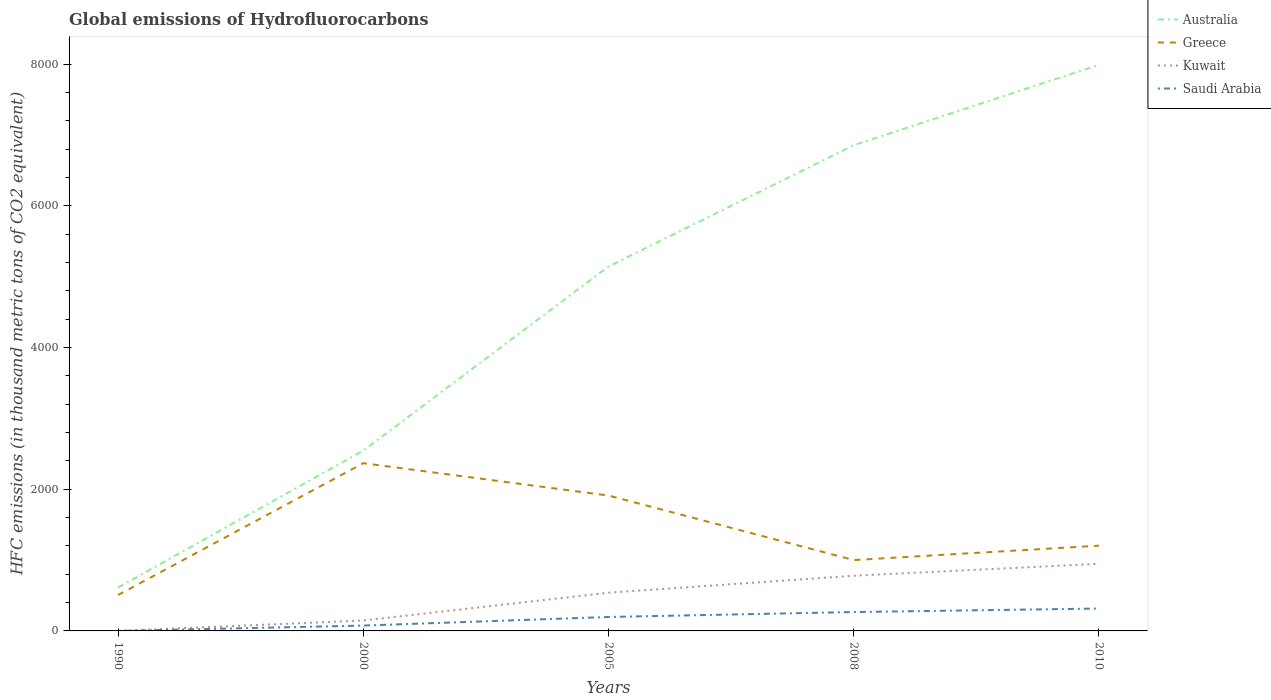Is the number of lines equal to the number of legend labels?
Provide a succinct answer. Yes. Across all years, what is the maximum global emissions of Hydrofluorocarbons in Australia?
Provide a short and direct response. 612.5. In which year was the global emissions of Hydrofluorocarbons in Australia maximum?
Your answer should be very brief. 1990. What is the total global emissions of Hydrofluorocarbons in Saudi Arabia in the graph?
Provide a succinct answer. -196.8. What is the difference between the highest and the second highest global emissions of Hydrofluorocarbons in Kuwait?
Ensure brevity in your answer.  947.9. How many years are there in the graph?
Make the answer very short. 5. What is the difference between two consecutive major ticks on the Y-axis?
Provide a short and direct response. 2000. Does the graph contain any zero values?
Provide a short and direct response. No. Does the graph contain grids?
Provide a succinct answer. No. Where does the legend appear in the graph?
Your response must be concise. Top right. How are the legend labels stacked?
Give a very brief answer. Vertical. What is the title of the graph?
Give a very brief answer. Global emissions of Hydrofluorocarbons. Does "Haiti" appear as one of the legend labels in the graph?
Give a very brief answer. No. What is the label or title of the Y-axis?
Ensure brevity in your answer.  HFC emissions (in thousand metric tons of CO2 equivalent). What is the HFC emissions (in thousand metric tons of CO2 equivalent) in Australia in 1990?
Make the answer very short. 612.5. What is the HFC emissions (in thousand metric tons of CO2 equivalent) in Greece in 1990?
Offer a very short reply. 507.2. What is the HFC emissions (in thousand metric tons of CO2 equivalent) of Australia in 2000?
Offer a very short reply. 2545.7. What is the HFC emissions (in thousand metric tons of CO2 equivalent) in Greece in 2000?
Give a very brief answer. 2368.4. What is the HFC emissions (in thousand metric tons of CO2 equivalent) of Kuwait in 2000?
Ensure brevity in your answer.  147.3. What is the HFC emissions (in thousand metric tons of CO2 equivalent) of Saudi Arabia in 2000?
Your response must be concise. 75.5. What is the HFC emissions (in thousand metric tons of CO2 equivalent) of Australia in 2005?
Keep it short and to the point. 5145.6. What is the HFC emissions (in thousand metric tons of CO2 equivalent) of Greece in 2005?
Your response must be concise. 1911.4. What is the HFC emissions (in thousand metric tons of CO2 equivalent) of Kuwait in 2005?
Make the answer very short. 539.6. What is the HFC emissions (in thousand metric tons of CO2 equivalent) of Saudi Arabia in 2005?
Your answer should be compact. 196.9. What is the HFC emissions (in thousand metric tons of CO2 equivalent) in Australia in 2008?
Offer a very short reply. 6857.4. What is the HFC emissions (in thousand metric tons of CO2 equivalent) in Greece in 2008?
Ensure brevity in your answer.  1000.3. What is the HFC emissions (in thousand metric tons of CO2 equivalent) of Kuwait in 2008?
Offer a terse response. 779. What is the HFC emissions (in thousand metric tons of CO2 equivalent) of Saudi Arabia in 2008?
Your answer should be compact. 266.5. What is the HFC emissions (in thousand metric tons of CO2 equivalent) of Australia in 2010?
Your answer should be very brief. 7992. What is the HFC emissions (in thousand metric tons of CO2 equivalent) in Greece in 2010?
Make the answer very short. 1204. What is the HFC emissions (in thousand metric tons of CO2 equivalent) in Kuwait in 2010?
Your answer should be compact. 948. What is the HFC emissions (in thousand metric tons of CO2 equivalent) in Saudi Arabia in 2010?
Ensure brevity in your answer.  316. Across all years, what is the maximum HFC emissions (in thousand metric tons of CO2 equivalent) of Australia?
Your answer should be compact. 7992. Across all years, what is the maximum HFC emissions (in thousand metric tons of CO2 equivalent) in Greece?
Your answer should be compact. 2368.4. Across all years, what is the maximum HFC emissions (in thousand metric tons of CO2 equivalent) in Kuwait?
Make the answer very short. 948. Across all years, what is the maximum HFC emissions (in thousand metric tons of CO2 equivalent) in Saudi Arabia?
Your answer should be compact. 316. Across all years, what is the minimum HFC emissions (in thousand metric tons of CO2 equivalent) of Australia?
Keep it short and to the point. 612.5. Across all years, what is the minimum HFC emissions (in thousand metric tons of CO2 equivalent) in Greece?
Your answer should be compact. 507.2. What is the total HFC emissions (in thousand metric tons of CO2 equivalent) in Australia in the graph?
Provide a succinct answer. 2.32e+04. What is the total HFC emissions (in thousand metric tons of CO2 equivalent) of Greece in the graph?
Your answer should be very brief. 6991.3. What is the total HFC emissions (in thousand metric tons of CO2 equivalent) of Kuwait in the graph?
Make the answer very short. 2414. What is the total HFC emissions (in thousand metric tons of CO2 equivalent) of Saudi Arabia in the graph?
Your answer should be very brief. 855. What is the difference between the HFC emissions (in thousand metric tons of CO2 equivalent) in Australia in 1990 and that in 2000?
Your response must be concise. -1933.2. What is the difference between the HFC emissions (in thousand metric tons of CO2 equivalent) in Greece in 1990 and that in 2000?
Offer a very short reply. -1861.2. What is the difference between the HFC emissions (in thousand metric tons of CO2 equivalent) of Kuwait in 1990 and that in 2000?
Keep it short and to the point. -147.2. What is the difference between the HFC emissions (in thousand metric tons of CO2 equivalent) of Saudi Arabia in 1990 and that in 2000?
Make the answer very short. -75.4. What is the difference between the HFC emissions (in thousand metric tons of CO2 equivalent) in Australia in 1990 and that in 2005?
Ensure brevity in your answer.  -4533.1. What is the difference between the HFC emissions (in thousand metric tons of CO2 equivalent) in Greece in 1990 and that in 2005?
Give a very brief answer. -1404.2. What is the difference between the HFC emissions (in thousand metric tons of CO2 equivalent) in Kuwait in 1990 and that in 2005?
Make the answer very short. -539.5. What is the difference between the HFC emissions (in thousand metric tons of CO2 equivalent) of Saudi Arabia in 1990 and that in 2005?
Keep it short and to the point. -196.8. What is the difference between the HFC emissions (in thousand metric tons of CO2 equivalent) of Australia in 1990 and that in 2008?
Your answer should be compact. -6244.9. What is the difference between the HFC emissions (in thousand metric tons of CO2 equivalent) in Greece in 1990 and that in 2008?
Give a very brief answer. -493.1. What is the difference between the HFC emissions (in thousand metric tons of CO2 equivalent) of Kuwait in 1990 and that in 2008?
Your answer should be compact. -778.9. What is the difference between the HFC emissions (in thousand metric tons of CO2 equivalent) of Saudi Arabia in 1990 and that in 2008?
Your response must be concise. -266.4. What is the difference between the HFC emissions (in thousand metric tons of CO2 equivalent) of Australia in 1990 and that in 2010?
Keep it short and to the point. -7379.5. What is the difference between the HFC emissions (in thousand metric tons of CO2 equivalent) in Greece in 1990 and that in 2010?
Ensure brevity in your answer.  -696.8. What is the difference between the HFC emissions (in thousand metric tons of CO2 equivalent) in Kuwait in 1990 and that in 2010?
Give a very brief answer. -947.9. What is the difference between the HFC emissions (in thousand metric tons of CO2 equivalent) of Saudi Arabia in 1990 and that in 2010?
Your response must be concise. -315.9. What is the difference between the HFC emissions (in thousand metric tons of CO2 equivalent) in Australia in 2000 and that in 2005?
Provide a short and direct response. -2599.9. What is the difference between the HFC emissions (in thousand metric tons of CO2 equivalent) in Greece in 2000 and that in 2005?
Your answer should be compact. 457. What is the difference between the HFC emissions (in thousand metric tons of CO2 equivalent) in Kuwait in 2000 and that in 2005?
Provide a short and direct response. -392.3. What is the difference between the HFC emissions (in thousand metric tons of CO2 equivalent) of Saudi Arabia in 2000 and that in 2005?
Offer a very short reply. -121.4. What is the difference between the HFC emissions (in thousand metric tons of CO2 equivalent) of Australia in 2000 and that in 2008?
Ensure brevity in your answer.  -4311.7. What is the difference between the HFC emissions (in thousand metric tons of CO2 equivalent) of Greece in 2000 and that in 2008?
Ensure brevity in your answer.  1368.1. What is the difference between the HFC emissions (in thousand metric tons of CO2 equivalent) in Kuwait in 2000 and that in 2008?
Your answer should be very brief. -631.7. What is the difference between the HFC emissions (in thousand metric tons of CO2 equivalent) in Saudi Arabia in 2000 and that in 2008?
Provide a succinct answer. -191. What is the difference between the HFC emissions (in thousand metric tons of CO2 equivalent) of Australia in 2000 and that in 2010?
Your answer should be very brief. -5446.3. What is the difference between the HFC emissions (in thousand metric tons of CO2 equivalent) in Greece in 2000 and that in 2010?
Offer a very short reply. 1164.4. What is the difference between the HFC emissions (in thousand metric tons of CO2 equivalent) in Kuwait in 2000 and that in 2010?
Provide a short and direct response. -800.7. What is the difference between the HFC emissions (in thousand metric tons of CO2 equivalent) in Saudi Arabia in 2000 and that in 2010?
Ensure brevity in your answer.  -240.5. What is the difference between the HFC emissions (in thousand metric tons of CO2 equivalent) in Australia in 2005 and that in 2008?
Provide a succinct answer. -1711.8. What is the difference between the HFC emissions (in thousand metric tons of CO2 equivalent) in Greece in 2005 and that in 2008?
Keep it short and to the point. 911.1. What is the difference between the HFC emissions (in thousand metric tons of CO2 equivalent) in Kuwait in 2005 and that in 2008?
Keep it short and to the point. -239.4. What is the difference between the HFC emissions (in thousand metric tons of CO2 equivalent) in Saudi Arabia in 2005 and that in 2008?
Offer a very short reply. -69.6. What is the difference between the HFC emissions (in thousand metric tons of CO2 equivalent) of Australia in 2005 and that in 2010?
Provide a succinct answer. -2846.4. What is the difference between the HFC emissions (in thousand metric tons of CO2 equivalent) of Greece in 2005 and that in 2010?
Keep it short and to the point. 707.4. What is the difference between the HFC emissions (in thousand metric tons of CO2 equivalent) of Kuwait in 2005 and that in 2010?
Offer a terse response. -408.4. What is the difference between the HFC emissions (in thousand metric tons of CO2 equivalent) of Saudi Arabia in 2005 and that in 2010?
Your answer should be compact. -119.1. What is the difference between the HFC emissions (in thousand metric tons of CO2 equivalent) in Australia in 2008 and that in 2010?
Keep it short and to the point. -1134.6. What is the difference between the HFC emissions (in thousand metric tons of CO2 equivalent) of Greece in 2008 and that in 2010?
Provide a short and direct response. -203.7. What is the difference between the HFC emissions (in thousand metric tons of CO2 equivalent) in Kuwait in 2008 and that in 2010?
Offer a very short reply. -169. What is the difference between the HFC emissions (in thousand metric tons of CO2 equivalent) of Saudi Arabia in 2008 and that in 2010?
Give a very brief answer. -49.5. What is the difference between the HFC emissions (in thousand metric tons of CO2 equivalent) in Australia in 1990 and the HFC emissions (in thousand metric tons of CO2 equivalent) in Greece in 2000?
Provide a succinct answer. -1755.9. What is the difference between the HFC emissions (in thousand metric tons of CO2 equivalent) in Australia in 1990 and the HFC emissions (in thousand metric tons of CO2 equivalent) in Kuwait in 2000?
Offer a terse response. 465.2. What is the difference between the HFC emissions (in thousand metric tons of CO2 equivalent) of Australia in 1990 and the HFC emissions (in thousand metric tons of CO2 equivalent) of Saudi Arabia in 2000?
Give a very brief answer. 537. What is the difference between the HFC emissions (in thousand metric tons of CO2 equivalent) in Greece in 1990 and the HFC emissions (in thousand metric tons of CO2 equivalent) in Kuwait in 2000?
Offer a terse response. 359.9. What is the difference between the HFC emissions (in thousand metric tons of CO2 equivalent) in Greece in 1990 and the HFC emissions (in thousand metric tons of CO2 equivalent) in Saudi Arabia in 2000?
Keep it short and to the point. 431.7. What is the difference between the HFC emissions (in thousand metric tons of CO2 equivalent) in Kuwait in 1990 and the HFC emissions (in thousand metric tons of CO2 equivalent) in Saudi Arabia in 2000?
Make the answer very short. -75.4. What is the difference between the HFC emissions (in thousand metric tons of CO2 equivalent) in Australia in 1990 and the HFC emissions (in thousand metric tons of CO2 equivalent) in Greece in 2005?
Give a very brief answer. -1298.9. What is the difference between the HFC emissions (in thousand metric tons of CO2 equivalent) in Australia in 1990 and the HFC emissions (in thousand metric tons of CO2 equivalent) in Kuwait in 2005?
Keep it short and to the point. 72.9. What is the difference between the HFC emissions (in thousand metric tons of CO2 equivalent) in Australia in 1990 and the HFC emissions (in thousand metric tons of CO2 equivalent) in Saudi Arabia in 2005?
Offer a terse response. 415.6. What is the difference between the HFC emissions (in thousand metric tons of CO2 equivalent) in Greece in 1990 and the HFC emissions (in thousand metric tons of CO2 equivalent) in Kuwait in 2005?
Your response must be concise. -32.4. What is the difference between the HFC emissions (in thousand metric tons of CO2 equivalent) in Greece in 1990 and the HFC emissions (in thousand metric tons of CO2 equivalent) in Saudi Arabia in 2005?
Your answer should be very brief. 310.3. What is the difference between the HFC emissions (in thousand metric tons of CO2 equivalent) in Kuwait in 1990 and the HFC emissions (in thousand metric tons of CO2 equivalent) in Saudi Arabia in 2005?
Offer a very short reply. -196.8. What is the difference between the HFC emissions (in thousand metric tons of CO2 equivalent) of Australia in 1990 and the HFC emissions (in thousand metric tons of CO2 equivalent) of Greece in 2008?
Your answer should be very brief. -387.8. What is the difference between the HFC emissions (in thousand metric tons of CO2 equivalent) of Australia in 1990 and the HFC emissions (in thousand metric tons of CO2 equivalent) of Kuwait in 2008?
Provide a succinct answer. -166.5. What is the difference between the HFC emissions (in thousand metric tons of CO2 equivalent) of Australia in 1990 and the HFC emissions (in thousand metric tons of CO2 equivalent) of Saudi Arabia in 2008?
Your response must be concise. 346. What is the difference between the HFC emissions (in thousand metric tons of CO2 equivalent) of Greece in 1990 and the HFC emissions (in thousand metric tons of CO2 equivalent) of Kuwait in 2008?
Give a very brief answer. -271.8. What is the difference between the HFC emissions (in thousand metric tons of CO2 equivalent) of Greece in 1990 and the HFC emissions (in thousand metric tons of CO2 equivalent) of Saudi Arabia in 2008?
Your answer should be compact. 240.7. What is the difference between the HFC emissions (in thousand metric tons of CO2 equivalent) in Kuwait in 1990 and the HFC emissions (in thousand metric tons of CO2 equivalent) in Saudi Arabia in 2008?
Keep it short and to the point. -266.4. What is the difference between the HFC emissions (in thousand metric tons of CO2 equivalent) of Australia in 1990 and the HFC emissions (in thousand metric tons of CO2 equivalent) of Greece in 2010?
Offer a terse response. -591.5. What is the difference between the HFC emissions (in thousand metric tons of CO2 equivalent) in Australia in 1990 and the HFC emissions (in thousand metric tons of CO2 equivalent) in Kuwait in 2010?
Provide a succinct answer. -335.5. What is the difference between the HFC emissions (in thousand metric tons of CO2 equivalent) of Australia in 1990 and the HFC emissions (in thousand metric tons of CO2 equivalent) of Saudi Arabia in 2010?
Your answer should be very brief. 296.5. What is the difference between the HFC emissions (in thousand metric tons of CO2 equivalent) of Greece in 1990 and the HFC emissions (in thousand metric tons of CO2 equivalent) of Kuwait in 2010?
Give a very brief answer. -440.8. What is the difference between the HFC emissions (in thousand metric tons of CO2 equivalent) in Greece in 1990 and the HFC emissions (in thousand metric tons of CO2 equivalent) in Saudi Arabia in 2010?
Your response must be concise. 191.2. What is the difference between the HFC emissions (in thousand metric tons of CO2 equivalent) in Kuwait in 1990 and the HFC emissions (in thousand metric tons of CO2 equivalent) in Saudi Arabia in 2010?
Provide a succinct answer. -315.9. What is the difference between the HFC emissions (in thousand metric tons of CO2 equivalent) of Australia in 2000 and the HFC emissions (in thousand metric tons of CO2 equivalent) of Greece in 2005?
Make the answer very short. 634.3. What is the difference between the HFC emissions (in thousand metric tons of CO2 equivalent) of Australia in 2000 and the HFC emissions (in thousand metric tons of CO2 equivalent) of Kuwait in 2005?
Your response must be concise. 2006.1. What is the difference between the HFC emissions (in thousand metric tons of CO2 equivalent) of Australia in 2000 and the HFC emissions (in thousand metric tons of CO2 equivalent) of Saudi Arabia in 2005?
Offer a terse response. 2348.8. What is the difference between the HFC emissions (in thousand metric tons of CO2 equivalent) in Greece in 2000 and the HFC emissions (in thousand metric tons of CO2 equivalent) in Kuwait in 2005?
Your answer should be compact. 1828.8. What is the difference between the HFC emissions (in thousand metric tons of CO2 equivalent) in Greece in 2000 and the HFC emissions (in thousand metric tons of CO2 equivalent) in Saudi Arabia in 2005?
Keep it short and to the point. 2171.5. What is the difference between the HFC emissions (in thousand metric tons of CO2 equivalent) of Kuwait in 2000 and the HFC emissions (in thousand metric tons of CO2 equivalent) of Saudi Arabia in 2005?
Your response must be concise. -49.6. What is the difference between the HFC emissions (in thousand metric tons of CO2 equivalent) in Australia in 2000 and the HFC emissions (in thousand metric tons of CO2 equivalent) in Greece in 2008?
Offer a very short reply. 1545.4. What is the difference between the HFC emissions (in thousand metric tons of CO2 equivalent) in Australia in 2000 and the HFC emissions (in thousand metric tons of CO2 equivalent) in Kuwait in 2008?
Your answer should be compact. 1766.7. What is the difference between the HFC emissions (in thousand metric tons of CO2 equivalent) in Australia in 2000 and the HFC emissions (in thousand metric tons of CO2 equivalent) in Saudi Arabia in 2008?
Your answer should be compact. 2279.2. What is the difference between the HFC emissions (in thousand metric tons of CO2 equivalent) in Greece in 2000 and the HFC emissions (in thousand metric tons of CO2 equivalent) in Kuwait in 2008?
Your answer should be compact. 1589.4. What is the difference between the HFC emissions (in thousand metric tons of CO2 equivalent) in Greece in 2000 and the HFC emissions (in thousand metric tons of CO2 equivalent) in Saudi Arabia in 2008?
Keep it short and to the point. 2101.9. What is the difference between the HFC emissions (in thousand metric tons of CO2 equivalent) in Kuwait in 2000 and the HFC emissions (in thousand metric tons of CO2 equivalent) in Saudi Arabia in 2008?
Your answer should be very brief. -119.2. What is the difference between the HFC emissions (in thousand metric tons of CO2 equivalent) of Australia in 2000 and the HFC emissions (in thousand metric tons of CO2 equivalent) of Greece in 2010?
Make the answer very short. 1341.7. What is the difference between the HFC emissions (in thousand metric tons of CO2 equivalent) in Australia in 2000 and the HFC emissions (in thousand metric tons of CO2 equivalent) in Kuwait in 2010?
Offer a very short reply. 1597.7. What is the difference between the HFC emissions (in thousand metric tons of CO2 equivalent) in Australia in 2000 and the HFC emissions (in thousand metric tons of CO2 equivalent) in Saudi Arabia in 2010?
Give a very brief answer. 2229.7. What is the difference between the HFC emissions (in thousand metric tons of CO2 equivalent) of Greece in 2000 and the HFC emissions (in thousand metric tons of CO2 equivalent) of Kuwait in 2010?
Offer a terse response. 1420.4. What is the difference between the HFC emissions (in thousand metric tons of CO2 equivalent) of Greece in 2000 and the HFC emissions (in thousand metric tons of CO2 equivalent) of Saudi Arabia in 2010?
Your response must be concise. 2052.4. What is the difference between the HFC emissions (in thousand metric tons of CO2 equivalent) of Kuwait in 2000 and the HFC emissions (in thousand metric tons of CO2 equivalent) of Saudi Arabia in 2010?
Give a very brief answer. -168.7. What is the difference between the HFC emissions (in thousand metric tons of CO2 equivalent) of Australia in 2005 and the HFC emissions (in thousand metric tons of CO2 equivalent) of Greece in 2008?
Ensure brevity in your answer.  4145.3. What is the difference between the HFC emissions (in thousand metric tons of CO2 equivalent) in Australia in 2005 and the HFC emissions (in thousand metric tons of CO2 equivalent) in Kuwait in 2008?
Your answer should be compact. 4366.6. What is the difference between the HFC emissions (in thousand metric tons of CO2 equivalent) in Australia in 2005 and the HFC emissions (in thousand metric tons of CO2 equivalent) in Saudi Arabia in 2008?
Offer a very short reply. 4879.1. What is the difference between the HFC emissions (in thousand metric tons of CO2 equivalent) in Greece in 2005 and the HFC emissions (in thousand metric tons of CO2 equivalent) in Kuwait in 2008?
Ensure brevity in your answer.  1132.4. What is the difference between the HFC emissions (in thousand metric tons of CO2 equivalent) in Greece in 2005 and the HFC emissions (in thousand metric tons of CO2 equivalent) in Saudi Arabia in 2008?
Give a very brief answer. 1644.9. What is the difference between the HFC emissions (in thousand metric tons of CO2 equivalent) in Kuwait in 2005 and the HFC emissions (in thousand metric tons of CO2 equivalent) in Saudi Arabia in 2008?
Keep it short and to the point. 273.1. What is the difference between the HFC emissions (in thousand metric tons of CO2 equivalent) of Australia in 2005 and the HFC emissions (in thousand metric tons of CO2 equivalent) of Greece in 2010?
Provide a short and direct response. 3941.6. What is the difference between the HFC emissions (in thousand metric tons of CO2 equivalent) of Australia in 2005 and the HFC emissions (in thousand metric tons of CO2 equivalent) of Kuwait in 2010?
Your answer should be compact. 4197.6. What is the difference between the HFC emissions (in thousand metric tons of CO2 equivalent) of Australia in 2005 and the HFC emissions (in thousand metric tons of CO2 equivalent) of Saudi Arabia in 2010?
Make the answer very short. 4829.6. What is the difference between the HFC emissions (in thousand metric tons of CO2 equivalent) of Greece in 2005 and the HFC emissions (in thousand metric tons of CO2 equivalent) of Kuwait in 2010?
Your answer should be compact. 963.4. What is the difference between the HFC emissions (in thousand metric tons of CO2 equivalent) in Greece in 2005 and the HFC emissions (in thousand metric tons of CO2 equivalent) in Saudi Arabia in 2010?
Your response must be concise. 1595.4. What is the difference between the HFC emissions (in thousand metric tons of CO2 equivalent) of Kuwait in 2005 and the HFC emissions (in thousand metric tons of CO2 equivalent) of Saudi Arabia in 2010?
Your answer should be very brief. 223.6. What is the difference between the HFC emissions (in thousand metric tons of CO2 equivalent) in Australia in 2008 and the HFC emissions (in thousand metric tons of CO2 equivalent) in Greece in 2010?
Your answer should be compact. 5653.4. What is the difference between the HFC emissions (in thousand metric tons of CO2 equivalent) in Australia in 2008 and the HFC emissions (in thousand metric tons of CO2 equivalent) in Kuwait in 2010?
Give a very brief answer. 5909.4. What is the difference between the HFC emissions (in thousand metric tons of CO2 equivalent) in Australia in 2008 and the HFC emissions (in thousand metric tons of CO2 equivalent) in Saudi Arabia in 2010?
Offer a terse response. 6541.4. What is the difference between the HFC emissions (in thousand metric tons of CO2 equivalent) in Greece in 2008 and the HFC emissions (in thousand metric tons of CO2 equivalent) in Kuwait in 2010?
Make the answer very short. 52.3. What is the difference between the HFC emissions (in thousand metric tons of CO2 equivalent) in Greece in 2008 and the HFC emissions (in thousand metric tons of CO2 equivalent) in Saudi Arabia in 2010?
Provide a short and direct response. 684.3. What is the difference between the HFC emissions (in thousand metric tons of CO2 equivalent) of Kuwait in 2008 and the HFC emissions (in thousand metric tons of CO2 equivalent) of Saudi Arabia in 2010?
Ensure brevity in your answer.  463. What is the average HFC emissions (in thousand metric tons of CO2 equivalent) of Australia per year?
Offer a terse response. 4630.64. What is the average HFC emissions (in thousand metric tons of CO2 equivalent) in Greece per year?
Make the answer very short. 1398.26. What is the average HFC emissions (in thousand metric tons of CO2 equivalent) of Kuwait per year?
Offer a terse response. 482.8. What is the average HFC emissions (in thousand metric tons of CO2 equivalent) of Saudi Arabia per year?
Provide a short and direct response. 171. In the year 1990, what is the difference between the HFC emissions (in thousand metric tons of CO2 equivalent) in Australia and HFC emissions (in thousand metric tons of CO2 equivalent) in Greece?
Your answer should be very brief. 105.3. In the year 1990, what is the difference between the HFC emissions (in thousand metric tons of CO2 equivalent) of Australia and HFC emissions (in thousand metric tons of CO2 equivalent) of Kuwait?
Make the answer very short. 612.4. In the year 1990, what is the difference between the HFC emissions (in thousand metric tons of CO2 equivalent) in Australia and HFC emissions (in thousand metric tons of CO2 equivalent) in Saudi Arabia?
Ensure brevity in your answer.  612.4. In the year 1990, what is the difference between the HFC emissions (in thousand metric tons of CO2 equivalent) of Greece and HFC emissions (in thousand metric tons of CO2 equivalent) of Kuwait?
Your answer should be very brief. 507.1. In the year 1990, what is the difference between the HFC emissions (in thousand metric tons of CO2 equivalent) of Greece and HFC emissions (in thousand metric tons of CO2 equivalent) of Saudi Arabia?
Provide a succinct answer. 507.1. In the year 1990, what is the difference between the HFC emissions (in thousand metric tons of CO2 equivalent) in Kuwait and HFC emissions (in thousand metric tons of CO2 equivalent) in Saudi Arabia?
Provide a short and direct response. 0. In the year 2000, what is the difference between the HFC emissions (in thousand metric tons of CO2 equivalent) in Australia and HFC emissions (in thousand metric tons of CO2 equivalent) in Greece?
Ensure brevity in your answer.  177.3. In the year 2000, what is the difference between the HFC emissions (in thousand metric tons of CO2 equivalent) in Australia and HFC emissions (in thousand metric tons of CO2 equivalent) in Kuwait?
Offer a terse response. 2398.4. In the year 2000, what is the difference between the HFC emissions (in thousand metric tons of CO2 equivalent) of Australia and HFC emissions (in thousand metric tons of CO2 equivalent) of Saudi Arabia?
Offer a very short reply. 2470.2. In the year 2000, what is the difference between the HFC emissions (in thousand metric tons of CO2 equivalent) in Greece and HFC emissions (in thousand metric tons of CO2 equivalent) in Kuwait?
Make the answer very short. 2221.1. In the year 2000, what is the difference between the HFC emissions (in thousand metric tons of CO2 equivalent) of Greece and HFC emissions (in thousand metric tons of CO2 equivalent) of Saudi Arabia?
Provide a short and direct response. 2292.9. In the year 2000, what is the difference between the HFC emissions (in thousand metric tons of CO2 equivalent) of Kuwait and HFC emissions (in thousand metric tons of CO2 equivalent) of Saudi Arabia?
Ensure brevity in your answer.  71.8. In the year 2005, what is the difference between the HFC emissions (in thousand metric tons of CO2 equivalent) of Australia and HFC emissions (in thousand metric tons of CO2 equivalent) of Greece?
Give a very brief answer. 3234.2. In the year 2005, what is the difference between the HFC emissions (in thousand metric tons of CO2 equivalent) of Australia and HFC emissions (in thousand metric tons of CO2 equivalent) of Kuwait?
Give a very brief answer. 4606. In the year 2005, what is the difference between the HFC emissions (in thousand metric tons of CO2 equivalent) of Australia and HFC emissions (in thousand metric tons of CO2 equivalent) of Saudi Arabia?
Make the answer very short. 4948.7. In the year 2005, what is the difference between the HFC emissions (in thousand metric tons of CO2 equivalent) in Greece and HFC emissions (in thousand metric tons of CO2 equivalent) in Kuwait?
Offer a very short reply. 1371.8. In the year 2005, what is the difference between the HFC emissions (in thousand metric tons of CO2 equivalent) of Greece and HFC emissions (in thousand metric tons of CO2 equivalent) of Saudi Arabia?
Your answer should be very brief. 1714.5. In the year 2005, what is the difference between the HFC emissions (in thousand metric tons of CO2 equivalent) in Kuwait and HFC emissions (in thousand metric tons of CO2 equivalent) in Saudi Arabia?
Provide a short and direct response. 342.7. In the year 2008, what is the difference between the HFC emissions (in thousand metric tons of CO2 equivalent) in Australia and HFC emissions (in thousand metric tons of CO2 equivalent) in Greece?
Offer a terse response. 5857.1. In the year 2008, what is the difference between the HFC emissions (in thousand metric tons of CO2 equivalent) in Australia and HFC emissions (in thousand metric tons of CO2 equivalent) in Kuwait?
Offer a very short reply. 6078.4. In the year 2008, what is the difference between the HFC emissions (in thousand metric tons of CO2 equivalent) of Australia and HFC emissions (in thousand metric tons of CO2 equivalent) of Saudi Arabia?
Give a very brief answer. 6590.9. In the year 2008, what is the difference between the HFC emissions (in thousand metric tons of CO2 equivalent) in Greece and HFC emissions (in thousand metric tons of CO2 equivalent) in Kuwait?
Your response must be concise. 221.3. In the year 2008, what is the difference between the HFC emissions (in thousand metric tons of CO2 equivalent) in Greece and HFC emissions (in thousand metric tons of CO2 equivalent) in Saudi Arabia?
Provide a short and direct response. 733.8. In the year 2008, what is the difference between the HFC emissions (in thousand metric tons of CO2 equivalent) in Kuwait and HFC emissions (in thousand metric tons of CO2 equivalent) in Saudi Arabia?
Provide a succinct answer. 512.5. In the year 2010, what is the difference between the HFC emissions (in thousand metric tons of CO2 equivalent) in Australia and HFC emissions (in thousand metric tons of CO2 equivalent) in Greece?
Your answer should be compact. 6788. In the year 2010, what is the difference between the HFC emissions (in thousand metric tons of CO2 equivalent) in Australia and HFC emissions (in thousand metric tons of CO2 equivalent) in Kuwait?
Make the answer very short. 7044. In the year 2010, what is the difference between the HFC emissions (in thousand metric tons of CO2 equivalent) in Australia and HFC emissions (in thousand metric tons of CO2 equivalent) in Saudi Arabia?
Provide a succinct answer. 7676. In the year 2010, what is the difference between the HFC emissions (in thousand metric tons of CO2 equivalent) of Greece and HFC emissions (in thousand metric tons of CO2 equivalent) of Kuwait?
Keep it short and to the point. 256. In the year 2010, what is the difference between the HFC emissions (in thousand metric tons of CO2 equivalent) in Greece and HFC emissions (in thousand metric tons of CO2 equivalent) in Saudi Arabia?
Your answer should be very brief. 888. In the year 2010, what is the difference between the HFC emissions (in thousand metric tons of CO2 equivalent) in Kuwait and HFC emissions (in thousand metric tons of CO2 equivalent) in Saudi Arabia?
Keep it short and to the point. 632. What is the ratio of the HFC emissions (in thousand metric tons of CO2 equivalent) of Australia in 1990 to that in 2000?
Provide a succinct answer. 0.24. What is the ratio of the HFC emissions (in thousand metric tons of CO2 equivalent) in Greece in 1990 to that in 2000?
Make the answer very short. 0.21. What is the ratio of the HFC emissions (in thousand metric tons of CO2 equivalent) of Kuwait in 1990 to that in 2000?
Your answer should be compact. 0. What is the ratio of the HFC emissions (in thousand metric tons of CO2 equivalent) in Saudi Arabia in 1990 to that in 2000?
Offer a very short reply. 0. What is the ratio of the HFC emissions (in thousand metric tons of CO2 equivalent) in Australia in 1990 to that in 2005?
Offer a terse response. 0.12. What is the ratio of the HFC emissions (in thousand metric tons of CO2 equivalent) of Greece in 1990 to that in 2005?
Your answer should be compact. 0.27. What is the ratio of the HFC emissions (in thousand metric tons of CO2 equivalent) of Kuwait in 1990 to that in 2005?
Your response must be concise. 0. What is the ratio of the HFC emissions (in thousand metric tons of CO2 equivalent) of Australia in 1990 to that in 2008?
Offer a very short reply. 0.09. What is the ratio of the HFC emissions (in thousand metric tons of CO2 equivalent) of Greece in 1990 to that in 2008?
Ensure brevity in your answer.  0.51. What is the ratio of the HFC emissions (in thousand metric tons of CO2 equivalent) of Kuwait in 1990 to that in 2008?
Ensure brevity in your answer.  0. What is the ratio of the HFC emissions (in thousand metric tons of CO2 equivalent) of Australia in 1990 to that in 2010?
Your answer should be compact. 0.08. What is the ratio of the HFC emissions (in thousand metric tons of CO2 equivalent) in Greece in 1990 to that in 2010?
Offer a terse response. 0.42. What is the ratio of the HFC emissions (in thousand metric tons of CO2 equivalent) of Kuwait in 1990 to that in 2010?
Make the answer very short. 0. What is the ratio of the HFC emissions (in thousand metric tons of CO2 equivalent) in Australia in 2000 to that in 2005?
Your answer should be very brief. 0.49. What is the ratio of the HFC emissions (in thousand metric tons of CO2 equivalent) of Greece in 2000 to that in 2005?
Provide a short and direct response. 1.24. What is the ratio of the HFC emissions (in thousand metric tons of CO2 equivalent) of Kuwait in 2000 to that in 2005?
Provide a succinct answer. 0.27. What is the ratio of the HFC emissions (in thousand metric tons of CO2 equivalent) of Saudi Arabia in 2000 to that in 2005?
Your answer should be compact. 0.38. What is the ratio of the HFC emissions (in thousand metric tons of CO2 equivalent) in Australia in 2000 to that in 2008?
Your response must be concise. 0.37. What is the ratio of the HFC emissions (in thousand metric tons of CO2 equivalent) in Greece in 2000 to that in 2008?
Your answer should be very brief. 2.37. What is the ratio of the HFC emissions (in thousand metric tons of CO2 equivalent) in Kuwait in 2000 to that in 2008?
Your answer should be compact. 0.19. What is the ratio of the HFC emissions (in thousand metric tons of CO2 equivalent) of Saudi Arabia in 2000 to that in 2008?
Make the answer very short. 0.28. What is the ratio of the HFC emissions (in thousand metric tons of CO2 equivalent) of Australia in 2000 to that in 2010?
Offer a terse response. 0.32. What is the ratio of the HFC emissions (in thousand metric tons of CO2 equivalent) of Greece in 2000 to that in 2010?
Your answer should be compact. 1.97. What is the ratio of the HFC emissions (in thousand metric tons of CO2 equivalent) in Kuwait in 2000 to that in 2010?
Ensure brevity in your answer.  0.16. What is the ratio of the HFC emissions (in thousand metric tons of CO2 equivalent) of Saudi Arabia in 2000 to that in 2010?
Give a very brief answer. 0.24. What is the ratio of the HFC emissions (in thousand metric tons of CO2 equivalent) of Australia in 2005 to that in 2008?
Ensure brevity in your answer.  0.75. What is the ratio of the HFC emissions (in thousand metric tons of CO2 equivalent) in Greece in 2005 to that in 2008?
Offer a very short reply. 1.91. What is the ratio of the HFC emissions (in thousand metric tons of CO2 equivalent) in Kuwait in 2005 to that in 2008?
Your answer should be compact. 0.69. What is the ratio of the HFC emissions (in thousand metric tons of CO2 equivalent) of Saudi Arabia in 2005 to that in 2008?
Provide a short and direct response. 0.74. What is the ratio of the HFC emissions (in thousand metric tons of CO2 equivalent) of Australia in 2005 to that in 2010?
Your answer should be compact. 0.64. What is the ratio of the HFC emissions (in thousand metric tons of CO2 equivalent) in Greece in 2005 to that in 2010?
Ensure brevity in your answer.  1.59. What is the ratio of the HFC emissions (in thousand metric tons of CO2 equivalent) in Kuwait in 2005 to that in 2010?
Make the answer very short. 0.57. What is the ratio of the HFC emissions (in thousand metric tons of CO2 equivalent) in Saudi Arabia in 2005 to that in 2010?
Make the answer very short. 0.62. What is the ratio of the HFC emissions (in thousand metric tons of CO2 equivalent) in Australia in 2008 to that in 2010?
Provide a short and direct response. 0.86. What is the ratio of the HFC emissions (in thousand metric tons of CO2 equivalent) in Greece in 2008 to that in 2010?
Give a very brief answer. 0.83. What is the ratio of the HFC emissions (in thousand metric tons of CO2 equivalent) in Kuwait in 2008 to that in 2010?
Your answer should be very brief. 0.82. What is the ratio of the HFC emissions (in thousand metric tons of CO2 equivalent) of Saudi Arabia in 2008 to that in 2010?
Your answer should be compact. 0.84. What is the difference between the highest and the second highest HFC emissions (in thousand metric tons of CO2 equivalent) of Australia?
Your answer should be very brief. 1134.6. What is the difference between the highest and the second highest HFC emissions (in thousand metric tons of CO2 equivalent) in Greece?
Offer a terse response. 457. What is the difference between the highest and the second highest HFC emissions (in thousand metric tons of CO2 equivalent) of Kuwait?
Make the answer very short. 169. What is the difference between the highest and the second highest HFC emissions (in thousand metric tons of CO2 equivalent) of Saudi Arabia?
Keep it short and to the point. 49.5. What is the difference between the highest and the lowest HFC emissions (in thousand metric tons of CO2 equivalent) in Australia?
Your response must be concise. 7379.5. What is the difference between the highest and the lowest HFC emissions (in thousand metric tons of CO2 equivalent) in Greece?
Keep it short and to the point. 1861.2. What is the difference between the highest and the lowest HFC emissions (in thousand metric tons of CO2 equivalent) of Kuwait?
Your response must be concise. 947.9. What is the difference between the highest and the lowest HFC emissions (in thousand metric tons of CO2 equivalent) of Saudi Arabia?
Provide a succinct answer. 315.9. 